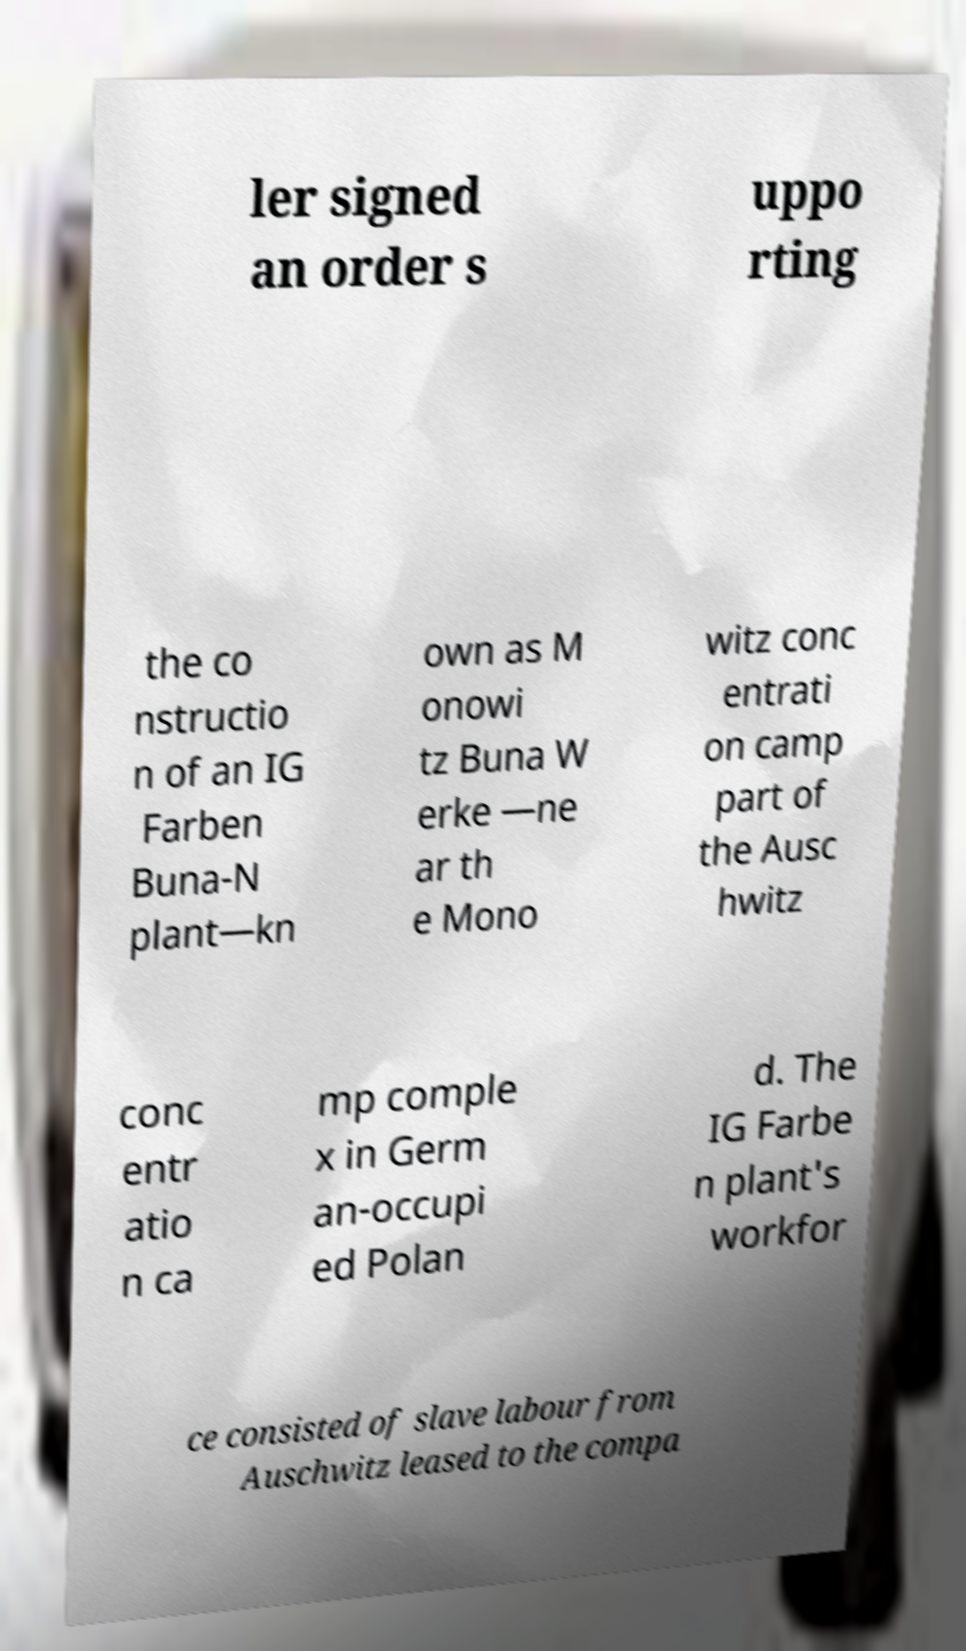Please identify and transcribe the text found in this image. ler signed an order s uppo rting the co nstructio n of an IG Farben Buna-N plant—kn own as M onowi tz Buna W erke —ne ar th e Mono witz conc entrati on camp part of the Ausc hwitz conc entr atio n ca mp comple x in Germ an-occupi ed Polan d. The IG Farbe n plant's workfor ce consisted of slave labour from Auschwitz leased to the compa 